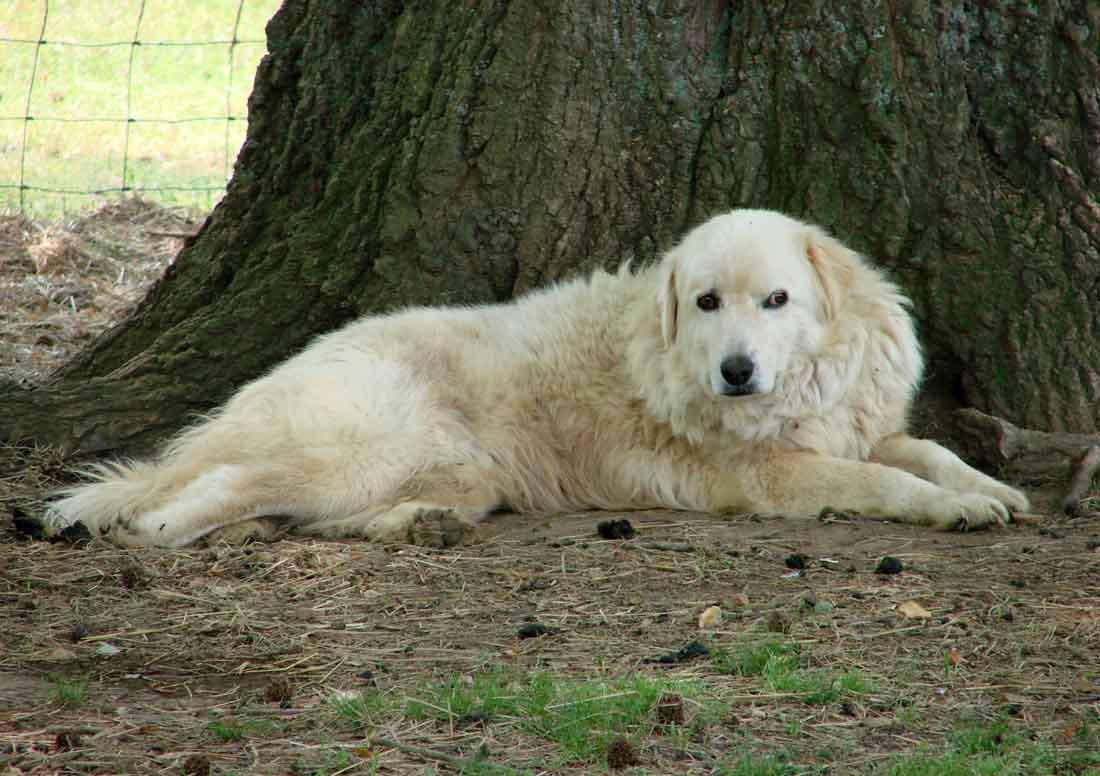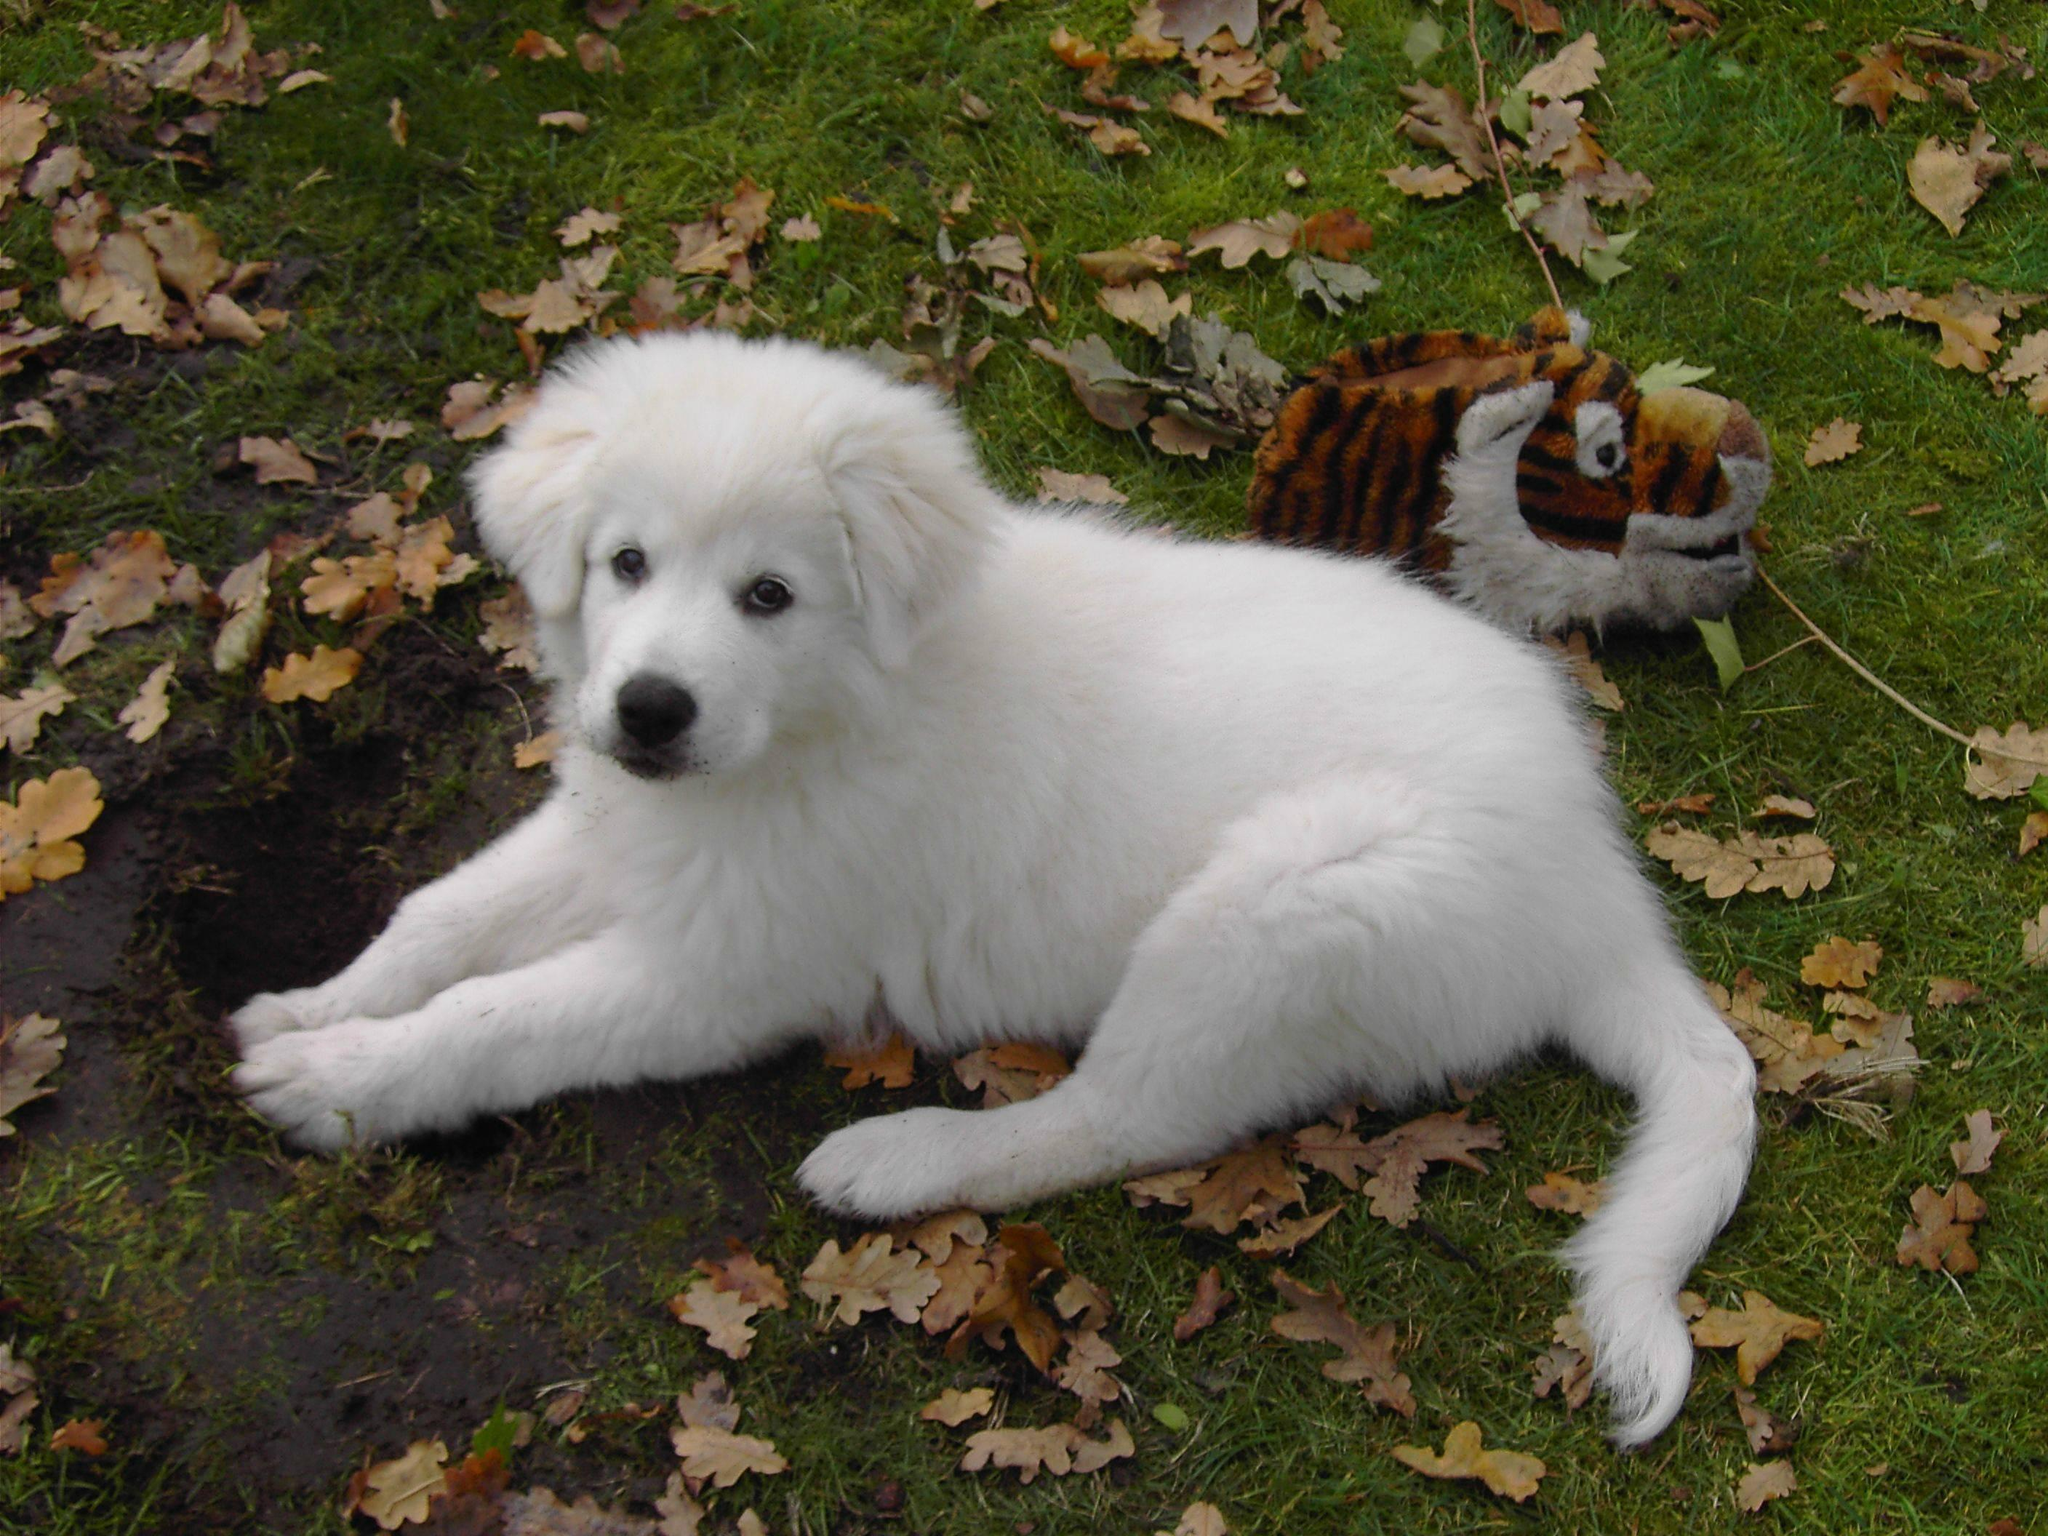The first image is the image on the left, the second image is the image on the right. For the images shown, is this caption "Exactly two large white dogs are standing upright." true? Answer yes or no. No. The first image is the image on the left, the second image is the image on the right. For the images shown, is this caption "There are only two dogs and both are standing with at least one of them on green grass." true? Answer yes or no. No. 